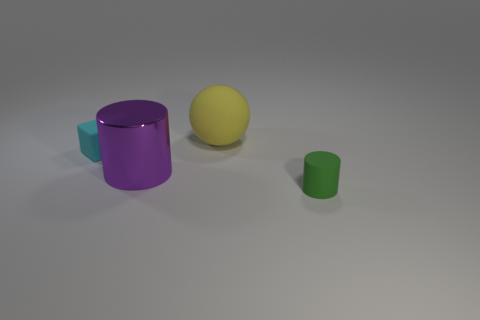Add 4 tiny green rubber cylinders. How many objects exist? 8 Subtract all blocks. How many objects are left? 3 Subtract all large purple matte things. Subtract all rubber things. How many objects are left? 1 Add 4 large yellow rubber spheres. How many large yellow rubber spheres are left? 5 Add 4 matte cubes. How many matte cubes exist? 5 Subtract 1 yellow balls. How many objects are left? 3 